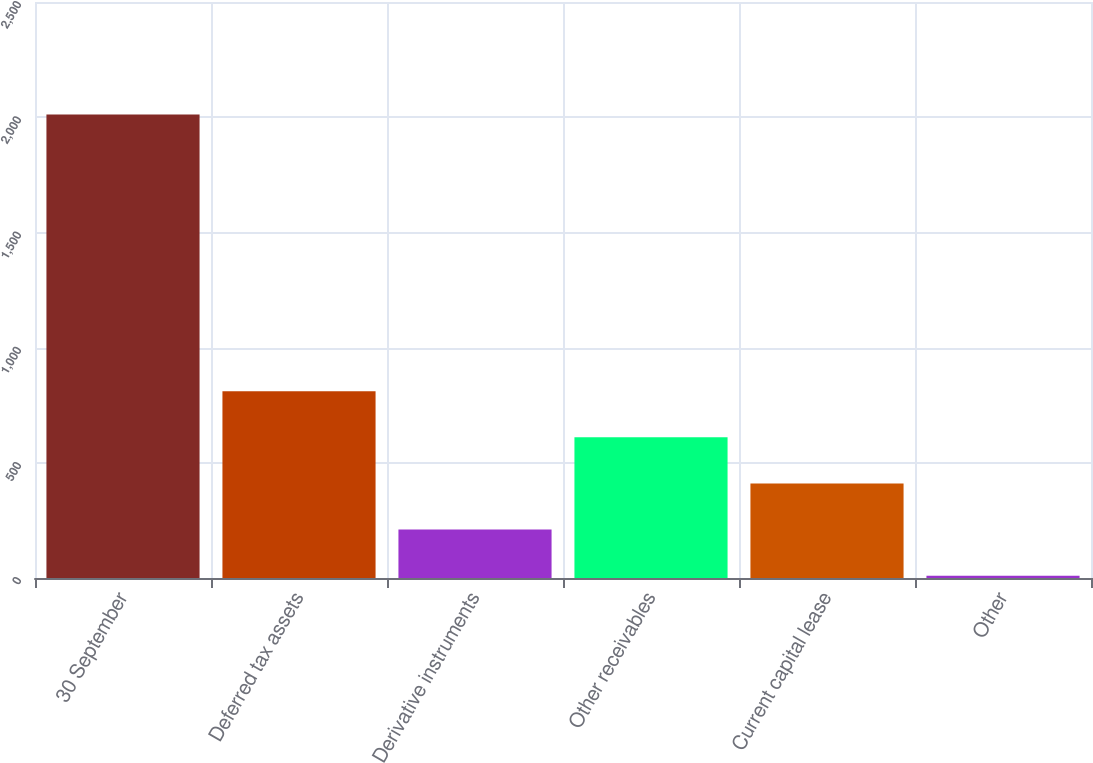<chart> <loc_0><loc_0><loc_500><loc_500><bar_chart><fcel>30 September<fcel>Deferred tax assets<fcel>Derivative instruments<fcel>Other receivables<fcel>Current capital lease<fcel>Other<nl><fcel>2012<fcel>810.8<fcel>210.2<fcel>610.6<fcel>410.4<fcel>10<nl></chart> 